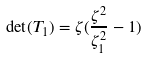Convert formula to latex. <formula><loc_0><loc_0><loc_500><loc_500>\det ( T _ { 1 } ) = \zeta ( \frac { \zeta ^ { 2 } } { \zeta _ { 1 } ^ { 2 } } - 1 )</formula> 